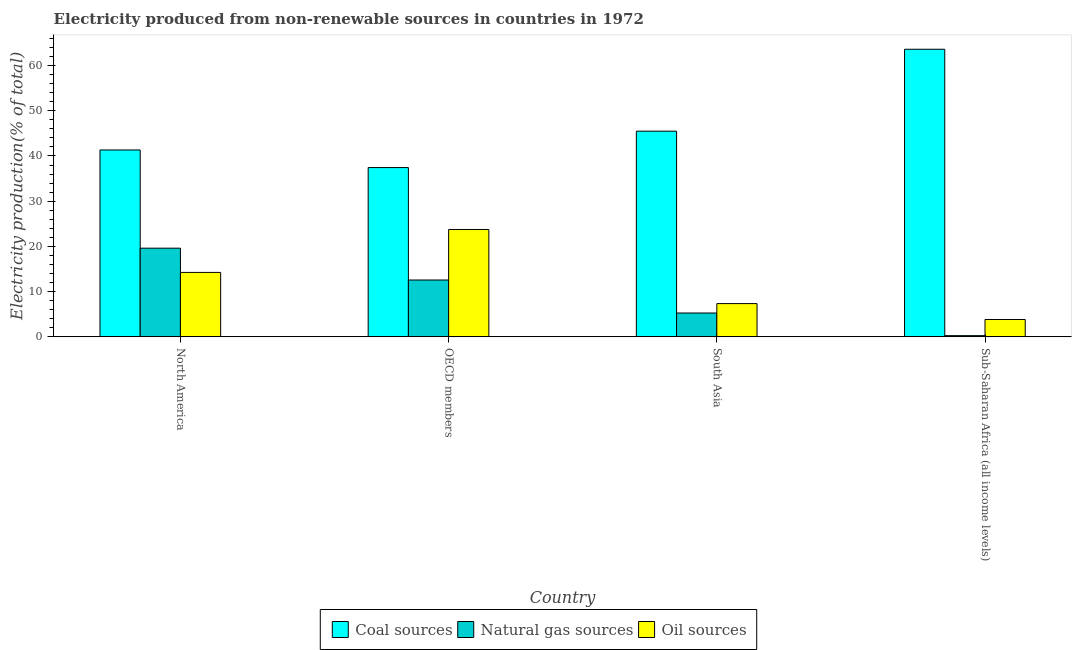How many different coloured bars are there?
Offer a very short reply. 3. Are the number of bars per tick equal to the number of legend labels?
Give a very brief answer. Yes. Are the number of bars on each tick of the X-axis equal?
Keep it short and to the point. Yes. How many bars are there on the 2nd tick from the left?
Offer a terse response. 3. How many bars are there on the 3rd tick from the right?
Make the answer very short. 3. What is the label of the 4th group of bars from the left?
Your answer should be very brief. Sub-Saharan Africa (all income levels). What is the percentage of electricity produced by oil sources in OECD members?
Give a very brief answer. 23.75. Across all countries, what is the maximum percentage of electricity produced by coal?
Provide a short and direct response. 63.61. Across all countries, what is the minimum percentage of electricity produced by coal?
Give a very brief answer. 37.44. In which country was the percentage of electricity produced by oil sources minimum?
Your response must be concise. Sub-Saharan Africa (all income levels). What is the total percentage of electricity produced by natural gas in the graph?
Give a very brief answer. 37.74. What is the difference between the percentage of electricity produced by natural gas in North America and that in OECD members?
Provide a succinct answer. 7.04. What is the difference between the percentage of electricity produced by natural gas in South Asia and the percentage of electricity produced by oil sources in North America?
Ensure brevity in your answer.  -8.97. What is the average percentage of electricity produced by coal per country?
Provide a short and direct response. 46.97. What is the difference between the percentage of electricity produced by oil sources and percentage of electricity produced by coal in South Asia?
Provide a short and direct response. -38.14. In how many countries, is the percentage of electricity produced by oil sources greater than 42 %?
Your answer should be very brief. 0. What is the ratio of the percentage of electricity produced by natural gas in OECD members to that in South Asia?
Ensure brevity in your answer.  2.38. What is the difference between the highest and the second highest percentage of electricity produced by natural gas?
Your answer should be very brief. 7.04. What is the difference between the highest and the lowest percentage of electricity produced by oil sources?
Provide a short and direct response. 19.91. What does the 1st bar from the left in Sub-Saharan Africa (all income levels) represents?
Provide a short and direct response. Coal sources. What does the 2nd bar from the right in North America represents?
Your answer should be compact. Natural gas sources. Is it the case that in every country, the sum of the percentage of electricity produced by coal and percentage of electricity produced by natural gas is greater than the percentage of electricity produced by oil sources?
Ensure brevity in your answer.  Yes. How many bars are there?
Provide a succinct answer. 12. How many countries are there in the graph?
Offer a terse response. 4. What is the difference between two consecutive major ticks on the Y-axis?
Provide a short and direct response. 10. Are the values on the major ticks of Y-axis written in scientific E-notation?
Keep it short and to the point. No. Does the graph contain any zero values?
Your answer should be very brief. No. How are the legend labels stacked?
Offer a terse response. Horizontal. What is the title of the graph?
Offer a terse response. Electricity produced from non-renewable sources in countries in 1972. Does "Taxes on international trade" appear as one of the legend labels in the graph?
Keep it short and to the point. No. What is the label or title of the X-axis?
Keep it short and to the point. Country. What is the Electricity production(% of total) in Coal sources in North America?
Provide a succinct answer. 41.33. What is the Electricity production(% of total) of Natural gas sources in North America?
Your answer should be very brief. 19.61. What is the Electricity production(% of total) in Oil sources in North America?
Give a very brief answer. 14.25. What is the Electricity production(% of total) in Coal sources in OECD members?
Provide a succinct answer. 37.44. What is the Electricity production(% of total) of Natural gas sources in OECD members?
Your response must be concise. 12.57. What is the Electricity production(% of total) in Oil sources in OECD members?
Provide a short and direct response. 23.75. What is the Electricity production(% of total) in Coal sources in South Asia?
Your answer should be very brief. 45.49. What is the Electricity production(% of total) of Natural gas sources in South Asia?
Ensure brevity in your answer.  5.28. What is the Electricity production(% of total) in Oil sources in South Asia?
Your answer should be very brief. 7.36. What is the Electricity production(% of total) of Coal sources in Sub-Saharan Africa (all income levels)?
Keep it short and to the point. 63.61. What is the Electricity production(% of total) in Natural gas sources in Sub-Saharan Africa (all income levels)?
Keep it short and to the point. 0.27. What is the Electricity production(% of total) in Oil sources in Sub-Saharan Africa (all income levels)?
Your response must be concise. 3.84. Across all countries, what is the maximum Electricity production(% of total) in Coal sources?
Provide a short and direct response. 63.61. Across all countries, what is the maximum Electricity production(% of total) in Natural gas sources?
Your response must be concise. 19.61. Across all countries, what is the maximum Electricity production(% of total) of Oil sources?
Offer a terse response. 23.75. Across all countries, what is the minimum Electricity production(% of total) of Coal sources?
Ensure brevity in your answer.  37.44. Across all countries, what is the minimum Electricity production(% of total) in Natural gas sources?
Offer a very short reply. 0.27. Across all countries, what is the minimum Electricity production(% of total) of Oil sources?
Your answer should be compact. 3.84. What is the total Electricity production(% of total) in Coal sources in the graph?
Give a very brief answer. 187.87. What is the total Electricity production(% of total) in Natural gas sources in the graph?
Keep it short and to the point. 37.74. What is the total Electricity production(% of total) in Oil sources in the graph?
Give a very brief answer. 49.2. What is the difference between the Electricity production(% of total) of Coal sources in North America and that in OECD members?
Ensure brevity in your answer.  3.89. What is the difference between the Electricity production(% of total) of Natural gas sources in North America and that in OECD members?
Your answer should be very brief. 7.04. What is the difference between the Electricity production(% of total) of Oil sources in North America and that in OECD members?
Give a very brief answer. -9.5. What is the difference between the Electricity production(% of total) in Coal sources in North America and that in South Asia?
Your answer should be very brief. -4.16. What is the difference between the Electricity production(% of total) of Natural gas sources in North America and that in South Asia?
Your response must be concise. 14.33. What is the difference between the Electricity production(% of total) in Oil sources in North America and that in South Asia?
Provide a short and direct response. 6.9. What is the difference between the Electricity production(% of total) of Coal sources in North America and that in Sub-Saharan Africa (all income levels)?
Your answer should be very brief. -22.27. What is the difference between the Electricity production(% of total) of Natural gas sources in North America and that in Sub-Saharan Africa (all income levels)?
Ensure brevity in your answer.  19.34. What is the difference between the Electricity production(% of total) in Oil sources in North America and that in Sub-Saharan Africa (all income levels)?
Provide a succinct answer. 10.41. What is the difference between the Electricity production(% of total) in Coal sources in OECD members and that in South Asia?
Make the answer very short. -8.05. What is the difference between the Electricity production(% of total) in Natural gas sources in OECD members and that in South Asia?
Give a very brief answer. 7.3. What is the difference between the Electricity production(% of total) in Oil sources in OECD members and that in South Asia?
Ensure brevity in your answer.  16.4. What is the difference between the Electricity production(% of total) of Coal sources in OECD members and that in Sub-Saharan Africa (all income levels)?
Offer a terse response. -26.17. What is the difference between the Electricity production(% of total) of Natural gas sources in OECD members and that in Sub-Saharan Africa (all income levels)?
Your answer should be compact. 12.3. What is the difference between the Electricity production(% of total) in Oil sources in OECD members and that in Sub-Saharan Africa (all income levels)?
Ensure brevity in your answer.  19.91. What is the difference between the Electricity production(% of total) of Coal sources in South Asia and that in Sub-Saharan Africa (all income levels)?
Provide a succinct answer. -18.11. What is the difference between the Electricity production(% of total) in Natural gas sources in South Asia and that in Sub-Saharan Africa (all income levels)?
Keep it short and to the point. 5.01. What is the difference between the Electricity production(% of total) of Oil sources in South Asia and that in Sub-Saharan Africa (all income levels)?
Ensure brevity in your answer.  3.51. What is the difference between the Electricity production(% of total) of Coal sources in North America and the Electricity production(% of total) of Natural gas sources in OECD members?
Your answer should be compact. 28.76. What is the difference between the Electricity production(% of total) in Coal sources in North America and the Electricity production(% of total) in Oil sources in OECD members?
Make the answer very short. 17.58. What is the difference between the Electricity production(% of total) of Natural gas sources in North America and the Electricity production(% of total) of Oil sources in OECD members?
Your answer should be compact. -4.14. What is the difference between the Electricity production(% of total) of Coal sources in North America and the Electricity production(% of total) of Natural gas sources in South Asia?
Give a very brief answer. 36.05. What is the difference between the Electricity production(% of total) of Coal sources in North America and the Electricity production(% of total) of Oil sources in South Asia?
Give a very brief answer. 33.98. What is the difference between the Electricity production(% of total) in Natural gas sources in North America and the Electricity production(% of total) in Oil sources in South Asia?
Your answer should be very brief. 12.26. What is the difference between the Electricity production(% of total) in Coal sources in North America and the Electricity production(% of total) in Natural gas sources in Sub-Saharan Africa (all income levels)?
Offer a terse response. 41.06. What is the difference between the Electricity production(% of total) in Coal sources in North America and the Electricity production(% of total) in Oil sources in Sub-Saharan Africa (all income levels)?
Keep it short and to the point. 37.49. What is the difference between the Electricity production(% of total) of Natural gas sources in North America and the Electricity production(% of total) of Oil sources in Sub-Saharan Africa (all income levels)?
Provide a short and direct response. 15.77. What is the difference between the Electricity production(% of total) of Coal sources in OECD members and the Electricity production(% of total) of Natural gas sources in South Asia?
Offer a terse response. 32.16. What is the difference between the Electricity production(% of total) of Coal sources in OECD members and the Electricity production(% of total) of Oil sources in South Asia?
Your answer should be compact. 30.08. What is the difference between the Electricity production(% of total) of Natural gas sources in OECD members and the Electricity production(% of total) of Oil sources in South Asia?
Keep it short and to the point. 5.22. What is the difference between the Electricity production(% of total) of Coal sources in OECD members and the Electricity production(% of total) of Natural gas sources in Sub-Saharan Africa (all income levels)?
Give a very brief answer. 37.17. What is the difference between the Electricity production(% of total) of Coal sources in OECD members and the Electricity production(% of total) of Oil sources in Sub-Saharan Africa (all income levels)?
Offer a very short reply. 33.59. What is the difference between the Electricity production(% of total) of Natural gas sources in OECD members and the Electricity production(% of total) of Oil sources in Sub-Saharan Africa (all income levels)?
Provide a short and direct response. 8.73. What is the difference between the Electricity production(% of total) of Coal sources in South Asia and the Electricity production(% of total) of Natural gas sources in Sub-Saharan Africa (all income levels)?
Keep it short and to the point. 45.22. What is the difference between the Electricity production(% of total) in Coal sources in South Asia and the Electricity production(% of total) in Oil sources in Sub-Saharan Africa (all income levels)?
Ensure brevity in your answer.  41.65. What is the difference between the Electricity production(% of total) of Natural gas sources in South Asia and the Electricity production(% of total) of Oil sources in Sub-Saharan Africa (all income levels)?
Give a very brief answer. 1.43. What is the average Electricity production(% of total) of Coal sources per country?
Make the answer very short. 46.97. What is the average Electricity production(% of total) in Natural gas sources per country?
Provide a succinct answer. 9.43. What is the average Electricity production(% of total) of Oil sources per country?
Keep it short and to the point. 12.3. What is the difference between the Electricity production(% of total) in Coal sources and Electricity production(% of total) in Natural gas sources in North America?
Your answer should be very brief. 21.72. What is the difference between the Electricity production(% of total) in Coal sources and Electricity production(% of total) in Oil sources in North America?
Provide a succinct answer. 27.08. What is the difference between the Electricity production(% of total) of Natural gas sources and Electricity production(% of total) of Oil sources in North America?
Your answer should be very brief. 5.36. What is the difference between the Electricity production(% of total) of Coal sources and Electricity production(% of total) of Natural gas sources in OECD members?
Ensure brevity in your answer.  24.86. What is the difference between the Electricity production(% of total) in Coal sources and Electricity production(% of total) in Oil sources in OECD members?
Give a very brief answer. 13.69. What is the difference between the Electricity production(% of total) in Natural gas sources and Electricity production(% of total) in Oil sources in OECD members?
Ensure brevity in your answer.  -11.18. What is the difference between the Electricity production(% of total) in Coal sources and Electricity production(% of total) in Natural gas sources in South Asia?
Offer a terse response. 40.21. What is the difference between the Electricity production(% of total) of Coal sources and Electricity production(% of total) of Oil sources in South Asia?
Offer a very short reply. 38.14. What is the difference between the Electricity production(% of total) of Natural gas sources and Electricity production(% of total) of Oil sources in South Asia?
Give a very brief answer. -2.08. What is the difference between the Electricity production(% of total) in Coal sources and Electricity production(% of total) in Natural gas sources in Sub-Saharan Africa (all income levels)?
Provide a short and direct response. 63.33. What is the difference between the Electricity production(% of total) of Coal sources and Electricity production(% of total) of Oil sources in Sub-Saharan Africa (all income levels)?
Keep it short and to the point. 59.76. What is the difference between the Electricity production(% of total) in Natural gas sources and Electricity production(% of total) in Oil sources in Sub-Saharan Africa (all income levels)?
Offer a very short reply. -3.57. What is the ratio of the Electricity production(% of total) in Coal sources in North America to that in OECD members?
Your answer should be compact. 1.1. What is the ratio of the Electricity production(% of total) of Natural gas sources in North America to that in OECD members?
Offer a very short reply. 1.56. What is the ratio of the Electricity production(% of total) in Oil sources in North America to that in OECD members?
Ensure brevity in your answer.  0.6. What is the ratio of the Electricity production(% of total) of Coal sources in North America to that in South Asia?
Provide a succinct answer. 0.91. What is the ratio of the Electricity production(% of total) in Natural gas sources in North America to that in South Asia?
Give a very brief answer. 3.72. What is the ratio of the Electricity production(% of total) in Oil sources in North America to that in South Asia?
Provide a short and direct response. 1.94. What is the ratio of the Electricity production(% of total) of Coal sources in North America to that in Sub-Saharan Africa (all income levels)?
Ensure brevity in your answer.  0.65. What is the ratio of the Electricity production(% of total) in Natural gas sources in North America to that in Sub-Saharan Africa (all income levels)?
Offer a terse response. 72.12. What is the ratio of the Electricity production(% of total) in Oil sources in North America to that in Sub-Saharan Africa (all income levels)?
Make the answer very short. 3.71. What is the ratio of the Electricity production(% of total) in Coal sources in OECD members to that in South Asia?
Offer a terse response. 0.82. What is the ratio of the Electricity production(% of total) in Natural gas sources in OECD members to that in South Asia?
Your answer should be compact. 2.38. What is the ratio of the Electricity production(% of total) in Oil sources in OECD members to that in South Asia?
Offer a very short reply. 3.23. What is the ratio of the Electricity production(% of total) in Coal sources in OECD members to that in Sub-Saharan Africa (all income levels)?
Your response must be concise. 0.59. What is the ratio of the Electricity production(% of total) of Natural gas sources in OECD members to that in Sub-Saharan Africa (all income levels)?
Provide a succinct answer. 46.24. What is the ratio of the Electricity production(% of total) of Oil sources in OECD members to that in Sub-Saharan Africa (all income levels)?
Your response must be concise. 6.18. What is the ratio of the Electricity production(% of total) in Coal sources in South Asia to that in Sub-Saharan Africa (all income levels)?
Your answer should be very brief. 0.72. What is the ratio of the Electricity production(% of total) of Natural gas sources in South Asia to that in Sub-Saharan Africa (all income levels)?
Ensure brevity in your answer.  19.41. What is the ratio of the Electricity production(% of total) of Oil sources in South Asia to that in Sub-Saharan Africa (all income levels)?
Your answer should be compact. 1.91. What is the difference between the highest and the second highest Electricity production(% of total) in Coal sources?
Your answer should be compact. 18.11. What is the difference between the highest and the second highest Electricity production(% of total) of Natural gas sources?
Your answer should be compact. 7.04. What is the difference between the highest and the second highest Electricity production(% of total) in Oil sources?
Offer a very short reply. 9.5. What is the difference between the highest and the lowest Electricity production(% of total) in Coal sources?
Keep it short and to the point. 26.17. What is the difference between the highest and the lowest Electricity production(% of total) in Natural gas sources?
Ensure brevity in your answer.  19.34. What is the difference between the highest and the lowest Electricity production(% of total) in Oil sources?
Offer a very short reply. 19.91. 